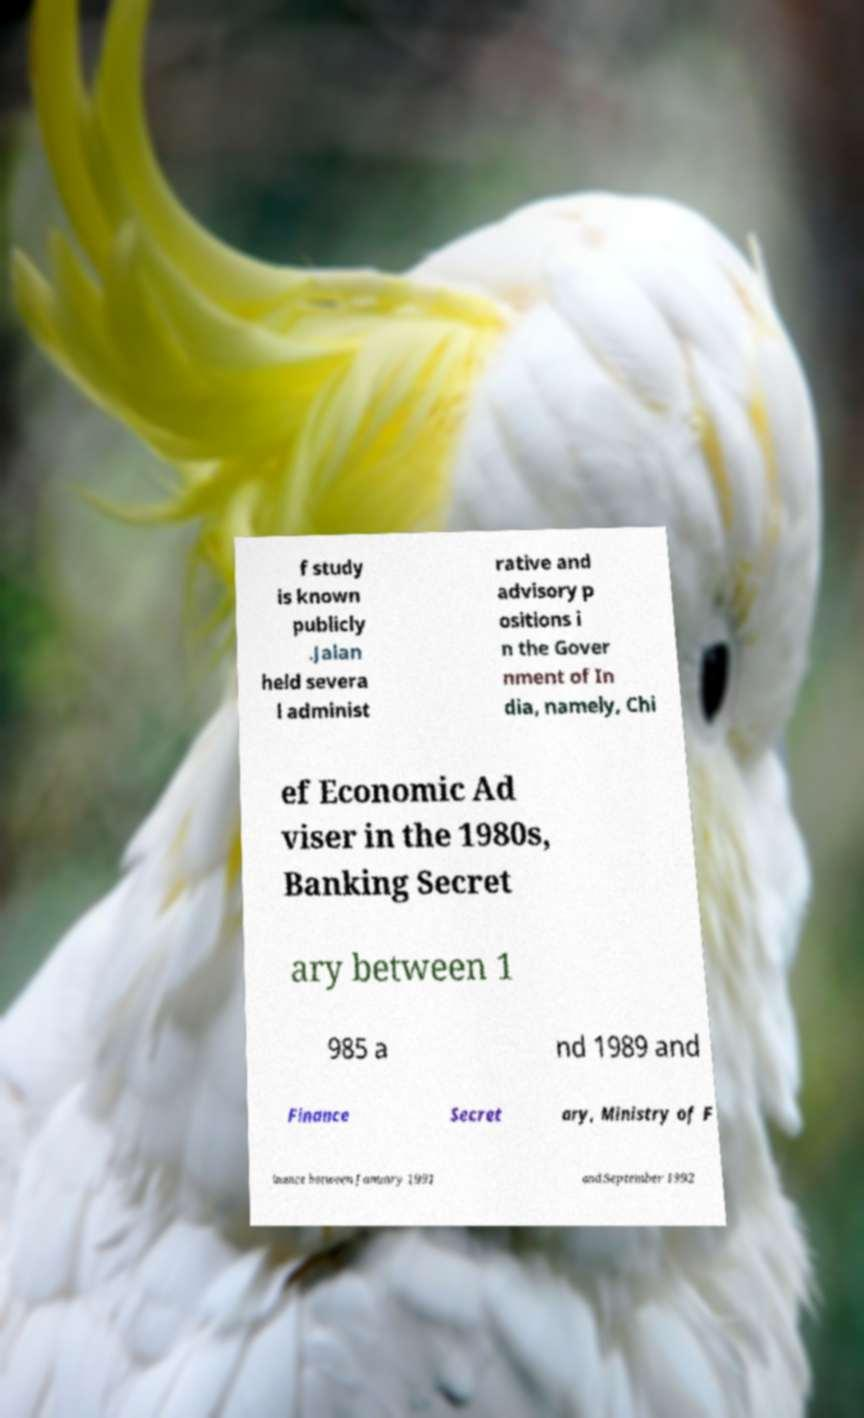Please identify and transcribe the text found in this image. f study is known publicly .Jalan held severa l administ rative and advisory p ositions i n the Gover nment of In dia, namely, Chi ef Economic Ad viser in the 1980s, Banking Secret ary between 1 985 a nd 1989 and Finance Secret ary, Ministry of F inance between January 1991 and September 1992 